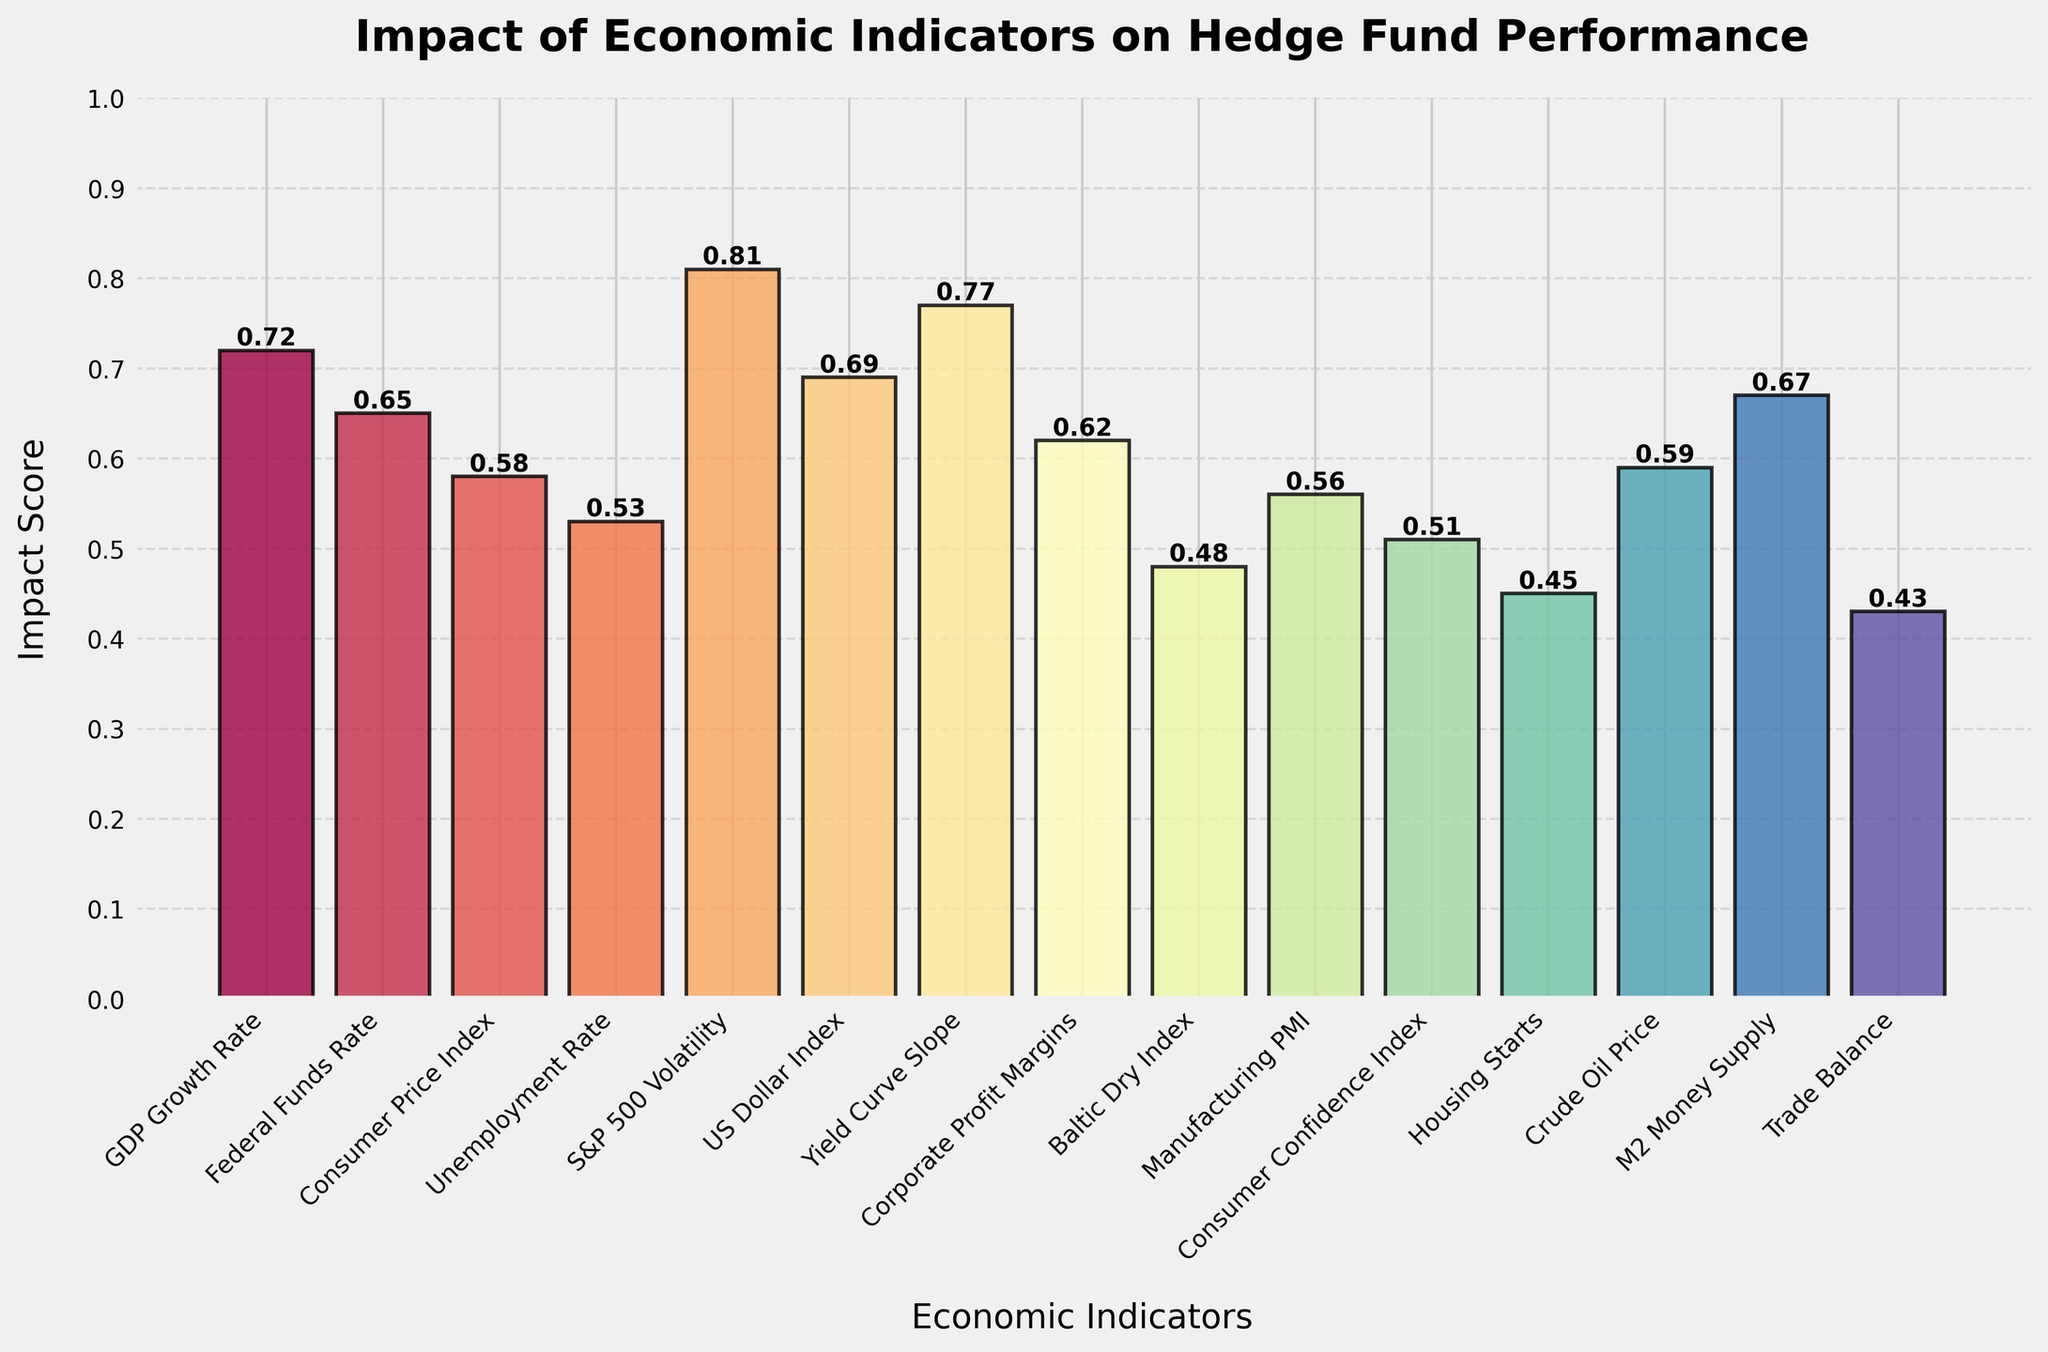What is the highest impact score among the economic indicators? By looking at the chart, the tallest bar represents the highest impact score. The S&P 500 Volatility bar is the tallest with an impact score of 0.81
Answer: 0.81 Which economic indicator has the lowest impact score? To find the lowest impact score, look for the shortest bar in the chart. The bar representing Trade Balance is the shortest with an impact score of 0.43
Answer: Trade Balance What are the top three economic indicators based on impact score? Look for the top three tallest bars in the chart. The indicators are S&P 500 Volatility (0.81), Yield Curve Slope (0.77), and GDP Growth Rate (0.72)
Answer: S&P 500 Volatility, Yield Curve Slope, GDP Growth Rate How much higher is the impact score of GDP Growth Rate compared to Housing Starts? GDP Growth Rate has an impact score of 0.72 and Housing Starts has an impact score of 0.45. The difference is 0.72 - 0.45
Answer: 0.27 Which economic indicator has an impact score closest to 0.6? Identify the bars with scores around 0.6: Corporate Profit Margins (0.62) and Crude Oil Price (0.59). Corporate Profit Margins (0.62) is closest to 0.6
Answer: Corporate Profit Margins What is the average impact score of the top 5 economic indicators? The top 5 indicators are S&P 500 Volatility (0.81), Yield Curve Slope (0.77), GDP Growth Rate (0.72), US Dollar Index (0.69), and M2 Money Supply (0.67). The average is (0.81+0.77+0.72+0.69+0.67)/5
Answer: 0.732 How do the impact scores of Consumer Price Index and Unemployment Rate compare? Consumer Price Index has an impact score of 0.58 while Unemployment Rate has 0.53. Consumer Price Index is higher by 0.05
Answer: Consumer Price Index is 0.05 higher Which economic indicator has a very similar impact score to M2 Money Supply? M2 Money Supply has an impact score of 0.67. US Dollar Index, with an impact score of 0.69, is very close
Answer: US Dollar Index What is the combined impact score of Consumer Confidence Index and Housing Starts? Consumer Confidence Index has an impact score of 0.51 and Housing Starts has 0.45. Their combined score is 0.51 + 0.45
Answer: 0.96 